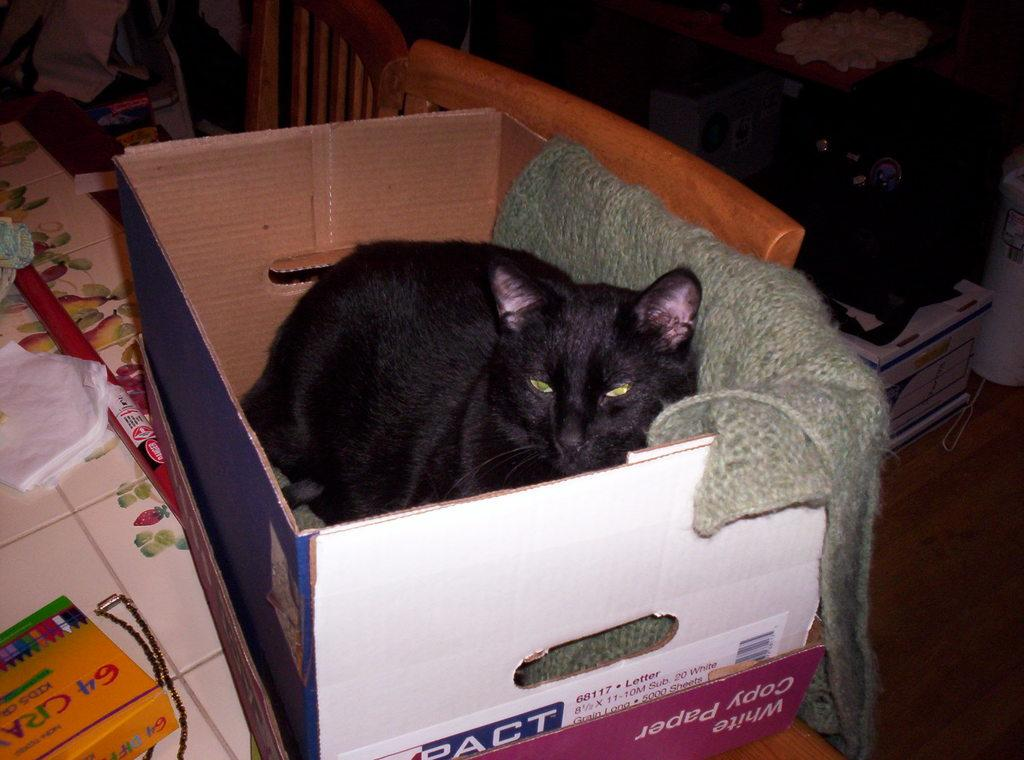<image>
Offer a succinct explanation of the picture presented. Black car sitting inside a box that used to contain white copy paper. 